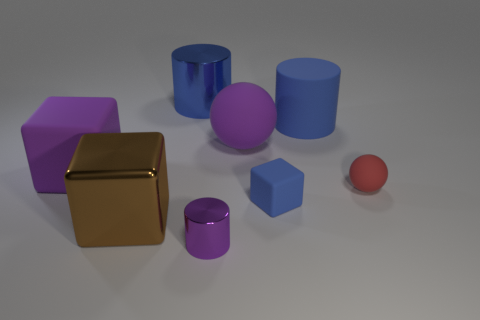Add 2 rubber things. How many objects exist? 10 Subtract 3 cylinders. How many cylinders are left? 0 Subtract all brown cylinders. Subtract all purple blocks. How many cylinders are left? 3 Subtract all purple blocks. How many blue cylinders are left? 2 Subtract all tiny blue matte cubes. Subtract all blue metallic objects. How many objects are left? 6 Add 5 large rubber balls. How many large rubber balls are left? 6 Add 1 blue blocks. How many blue blocks exist? 2 Subtract all red balls. How many balls are left? 1 Subtract all rubber blocks. How many blocks are left? 1 Subtract 0 brown balls. How many objects are left? 8 